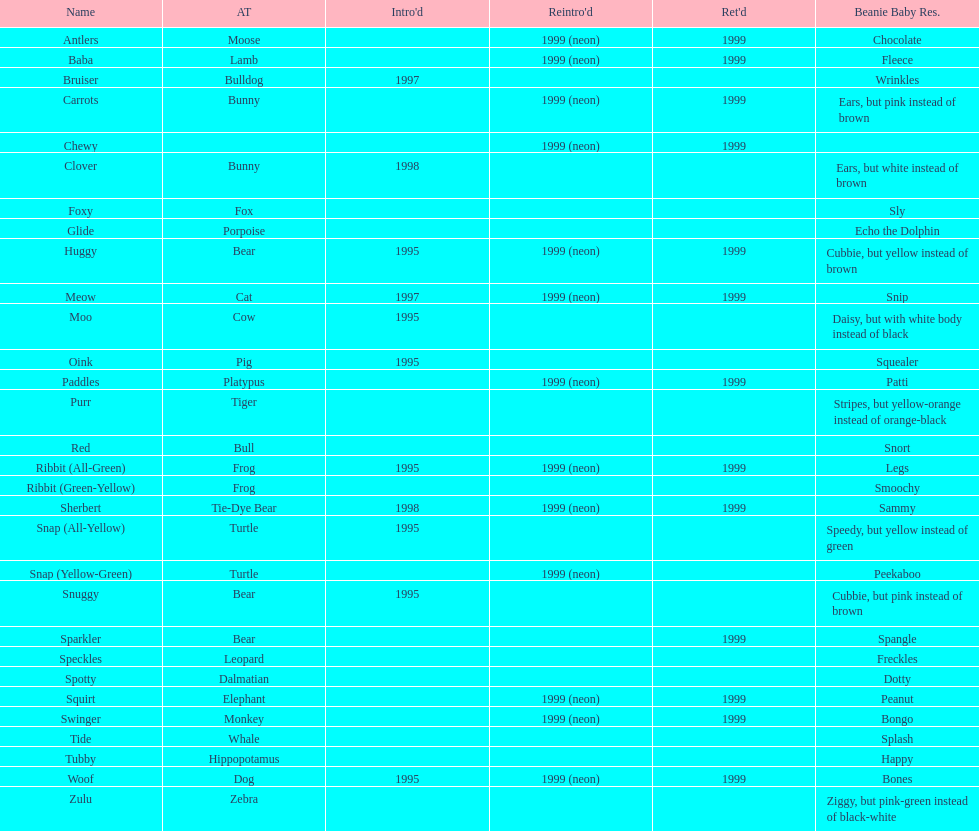What is the number of frog pillow pals? 2. 